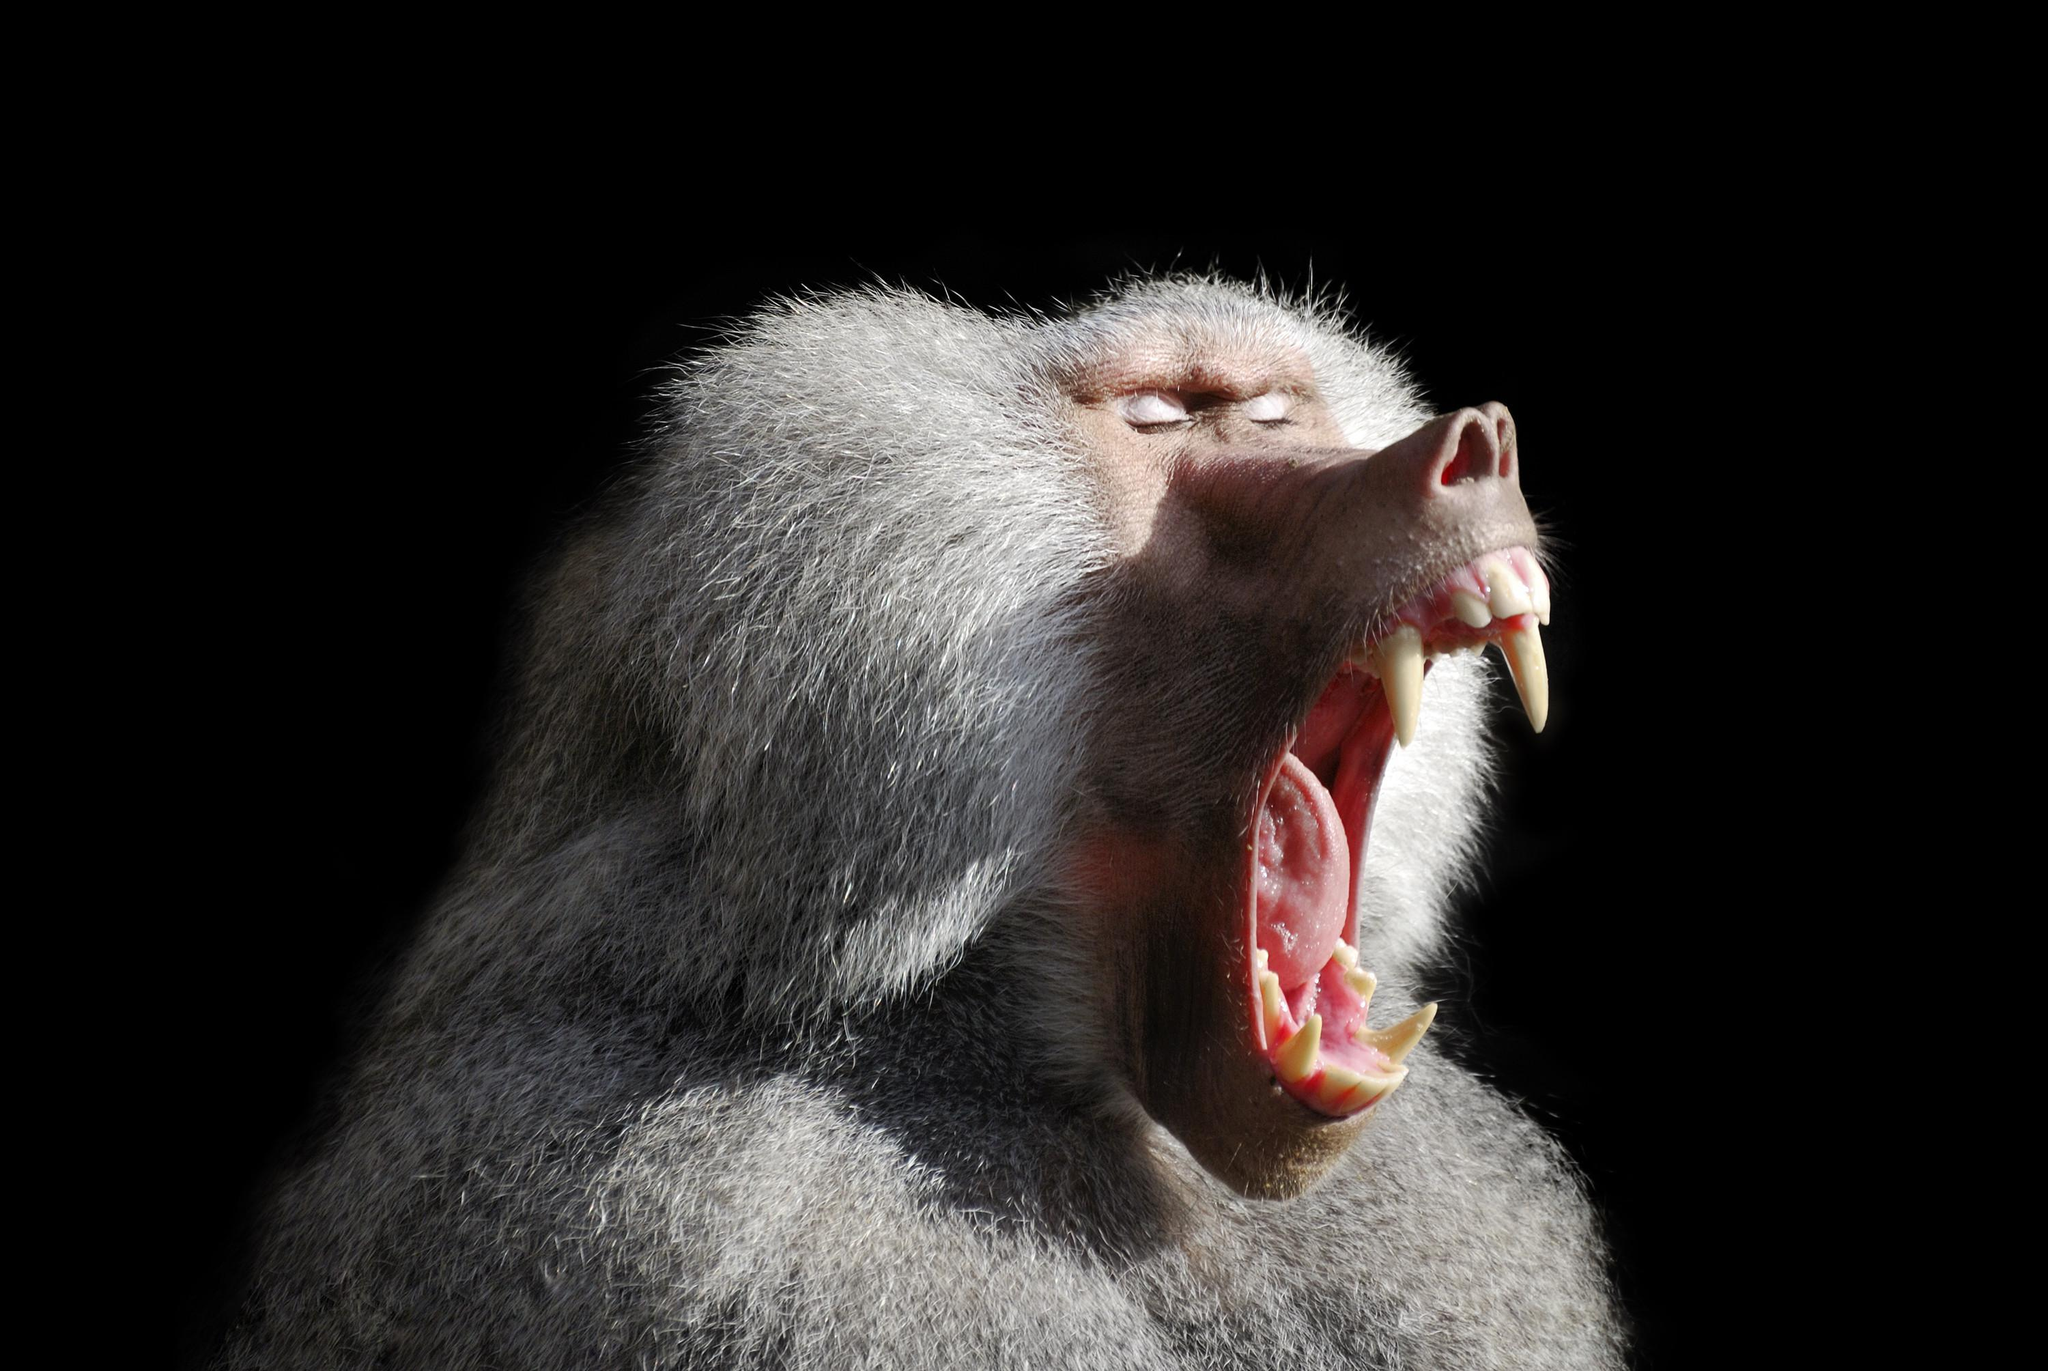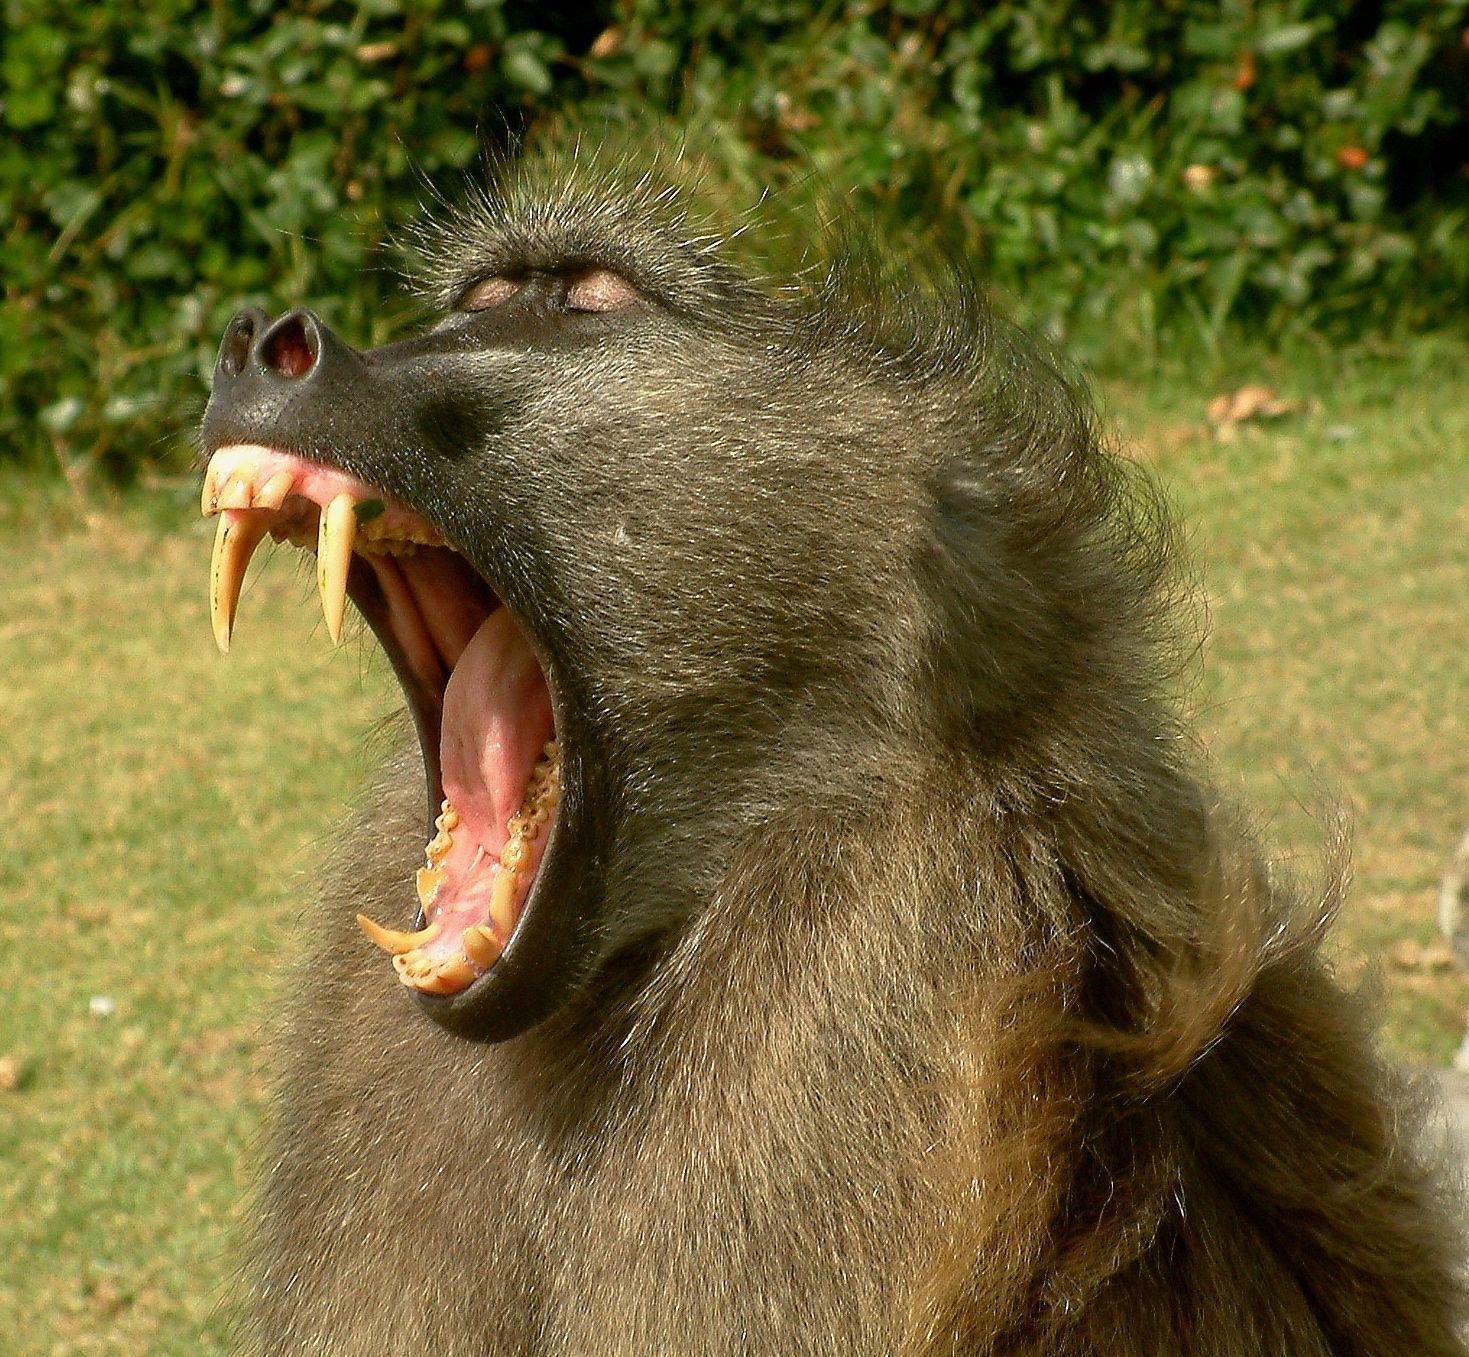The first image is the image on the left, the second image is the image on the right. Assess this claim about the two images: "There are at most two baboons.". Correct or not? Answer yes or no. Yes. The first image is the image on the left, the second image is the image on the right. Considering the images on both sides, is "There are at most two baboons." valid? Answer yes or no. Yes. 